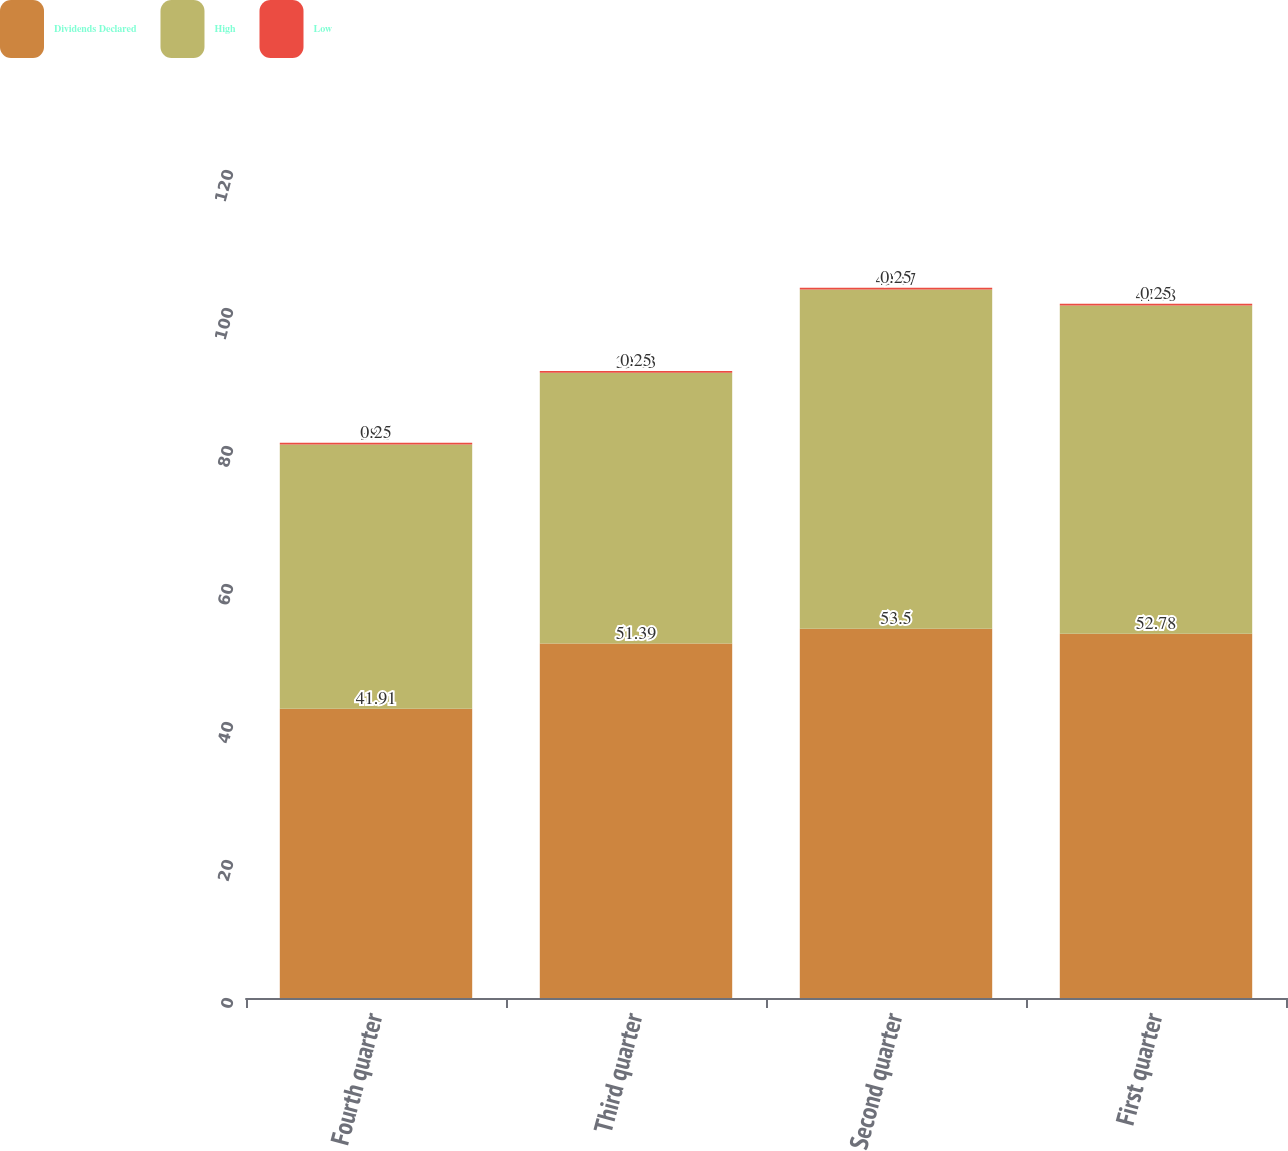Convert chart. <chart><loc_0><loc_0><loc_500><loc_500><stacked_bar_chart><ecel><fcel>Fourth quarter<fcel>Third quarter<fcel>Second quarter<fcel>First quarter<nl><fcel>Dividends Declared<fcel>41.91<fcel>51.39<fcel>53.5<fcel>52.78<nl><fcel>High<fcel>38.3<fcel>39.23<fcel>49.17<fcel>47.58<nl><fcel>Low<fcel>0.25<fcel>0.25<fcel>0.25<fcel>0.25<nl></chart> 